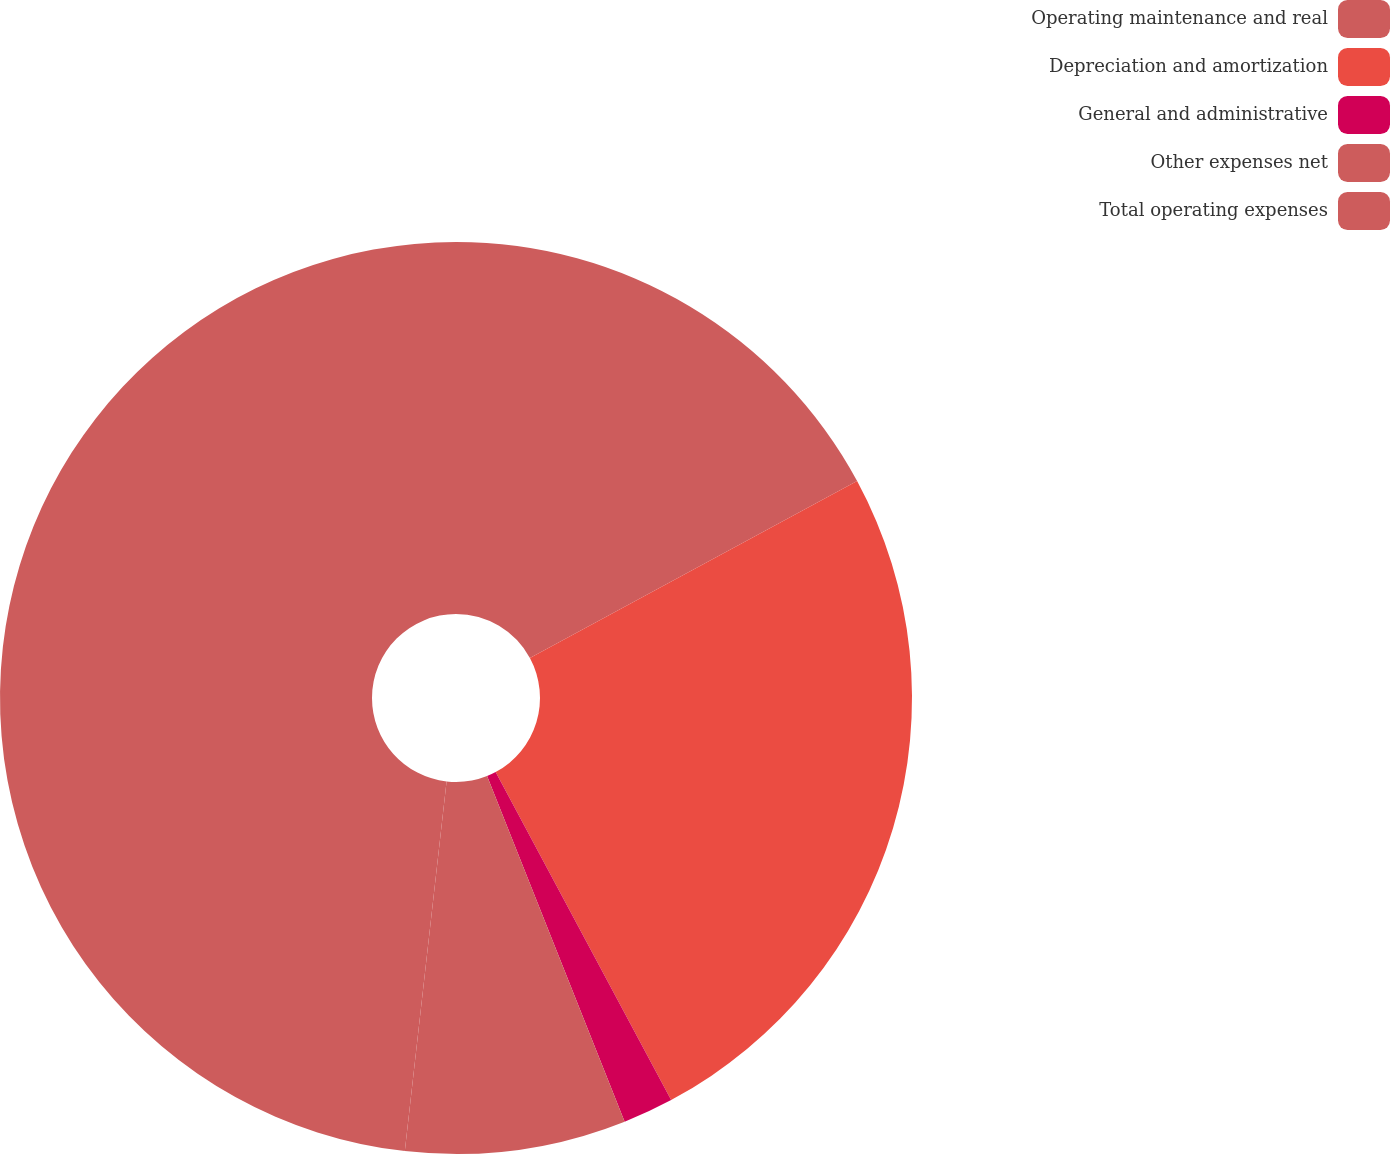Convert chart. <chart><loc_0><loc_0><loc_500><loc_500><pie_chart><fcel>Operating maintenance and real<fcel>Depreciation and amortization<fcel>General and administrative<fcel>Other expenses net<fcel>Total operating expenses<nl><fcel>17.11%<fcel>25.07%<fcel>1.79%<fcel>7.82%<fcel>48.21%<nl></chart> 